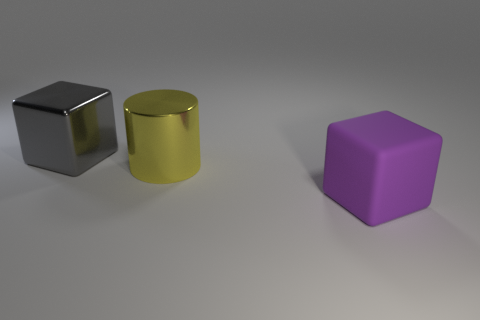What is the big cube to the left of the big purple thing made of?
Provide a short and direct response. Metal. Is there any other thing that has the same shape as the big gray object?
Offer a very short reply. Yes. How many shiny objects are gray objects or blocks?
Your answer should be compact. 1. Is the number of big yellow objects in front of the big shiny cylinder less than the number of yellow metal cylinders?
Offer a terse response. Yes. The big metallic thing behind the large yellow cylinder to the right of the metallic thing to the left of the big yellow shiny thing is what shape?
Provide a short and direct response. Cube. Is the large metallic block the same color as the large rubber cube?
Provide a short and direct response. No. Are there more big gray shiny cubes than tiny rubber things?
Keep it short and to the point. Yes. What number of other things are the same material as the yellow cylinder?
Ensure brevity in your answer.  1. What number of things are large purple matte blocks or big blocks that are behind the purple block?
Give a very brief answer. 2. Are there fewer matte objects than large brown metal balls?
Provide a short and direct response. No. 